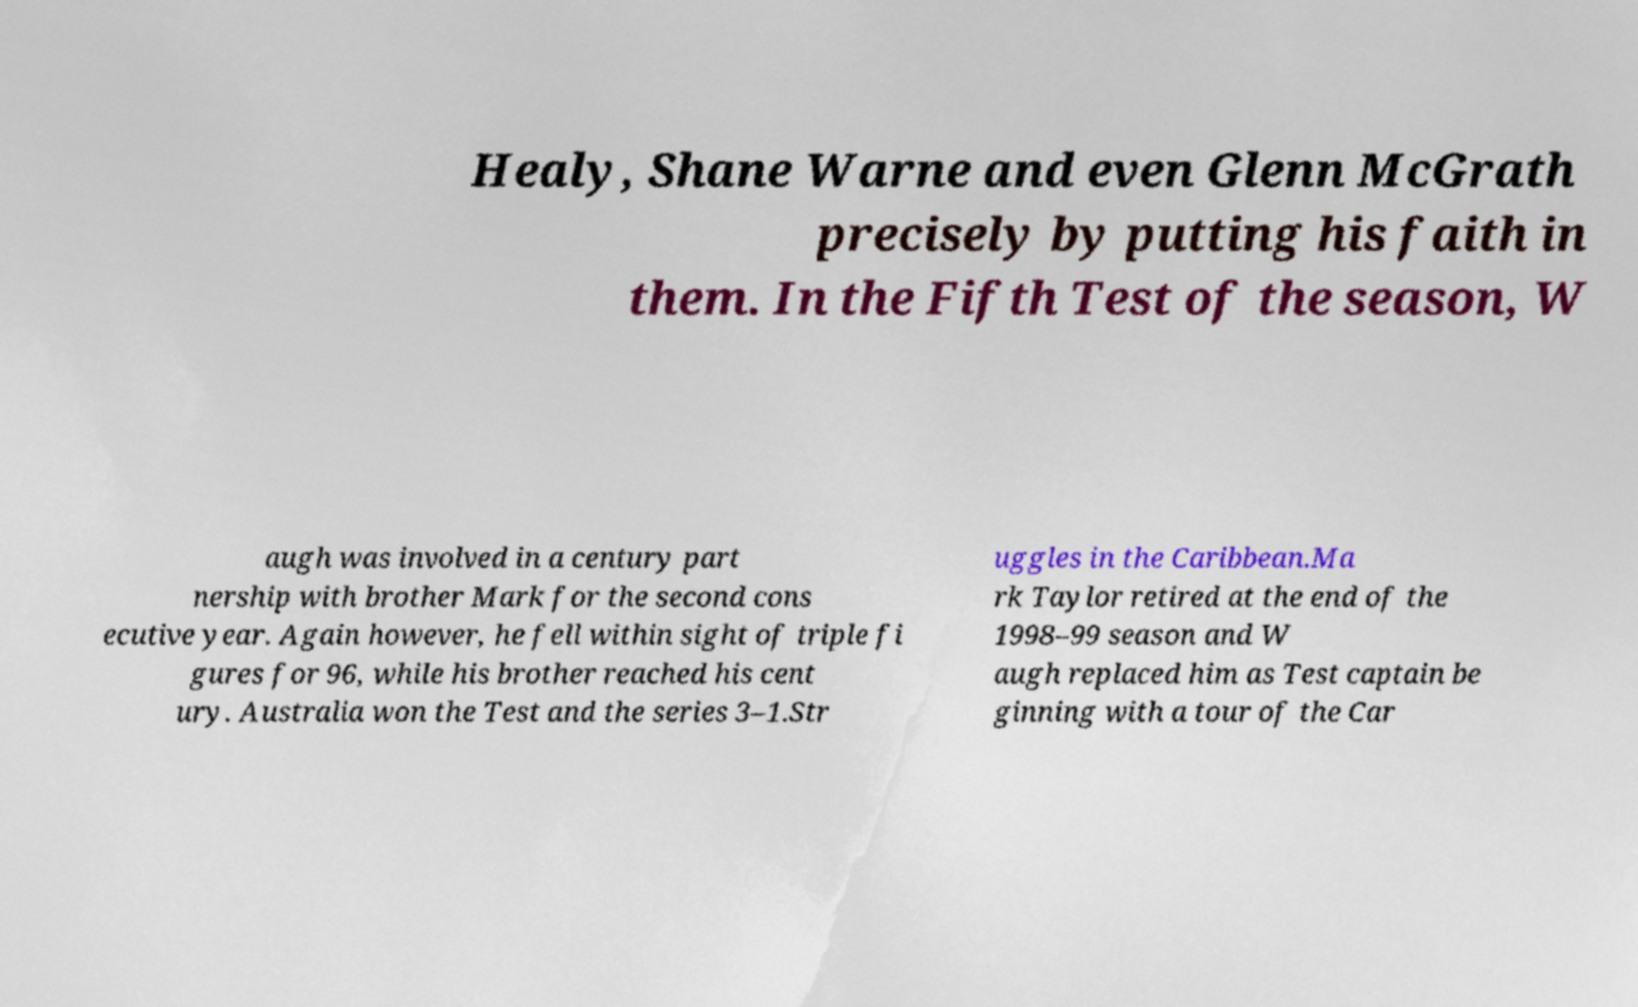Please identify and transcribe the text found in this image. Healy, Shane Warne and even Glenn McGrath precisely by putting his faith in them. In the Fifth Test of the season, W augh was involved in a century part nership with brother Mark for the second cons ecutive year. Again however, he fell within sight of triple fi gures for 96, while his brother reached his cent ury. Australia won the Test and the series 3–1.Str uggles in the Caribbean.Ma rk Taylor retired at the end of the 1998–99 season and W augh replaced him as Test captain be ginning with a tour of the Car 